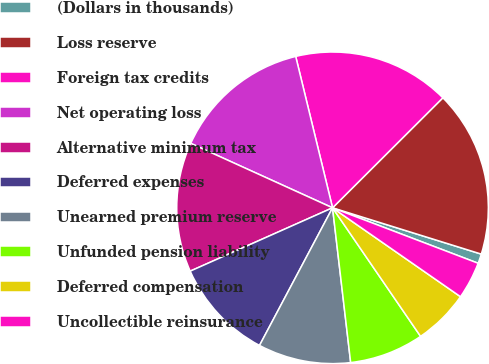Convert chart to OTSL. <chart><loc_0><loc_0><loc_500><loc_500><pie_chart><fcel>(Dollars in thousands)<fcel>Loss reserve<fcel>Foreign tax credits<fcel>Net operating loss<fcel>Alternative minimum tax<fcel>Deferred expenses<fcel>Unearned premium reserve<fcel>Unfunded pension liability<fcel>Deferred compensation<fcel>Uncollectible reinsurance<nl><fcel>0.99%<fcel>17.28%<fcel>16.32%<fcel>14.41%<fcel>13.45%<fcel>10.57%<fcel>9.62%<fcel>7.7%<fcel>5.78%<fcel>3.87%<nl></chart> 